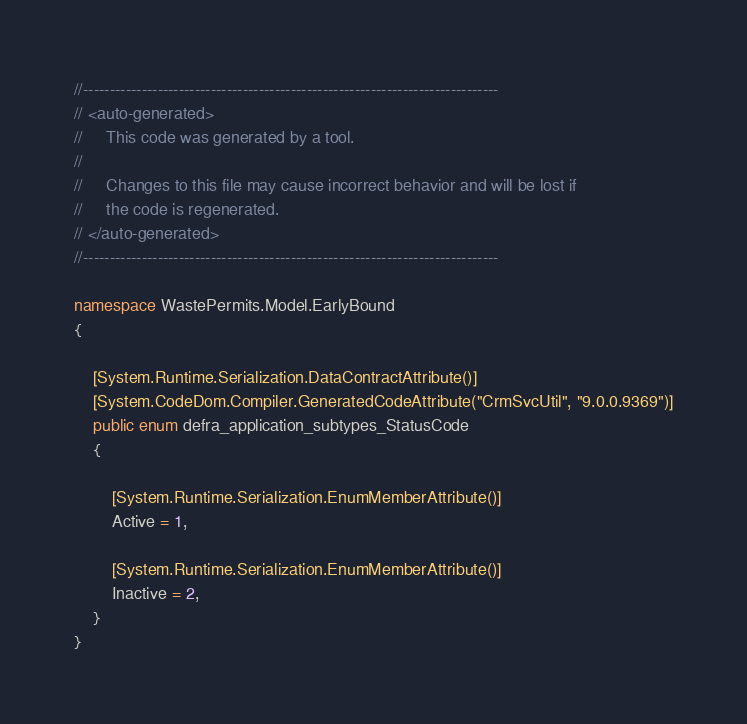<code> <loc_0><loc_0><loc_500><loc_500><_C#_>//------------------------------------------------------------------------------
// <auto-generated>
//     This code was generated by a tool.
//
//     Changes to this file may cause incorrect behavior and will be lost if
//     the code is regenerated.
// </auto-generated>
//------------------------------------------------------------------------------

namespace WastePermits.Model.EarlyBound
{
	
	[System.Runtime.Serialization.DataContractAttribute()]
	[System.CodeDom.Compiler.GeneratedCodeAttribute("CrmSvcUtil", "9.0.0.9369")]
	public enum defra_application_subtypes_StatusCode
	{
		
		[System.Runtime.Serialization.EnumMemberAttribute()]
		Active = 1,
		
		[System.Runtime.Serialization.EnumMemberAttribute()]
		Inactive = 2,
	}
}</code> 